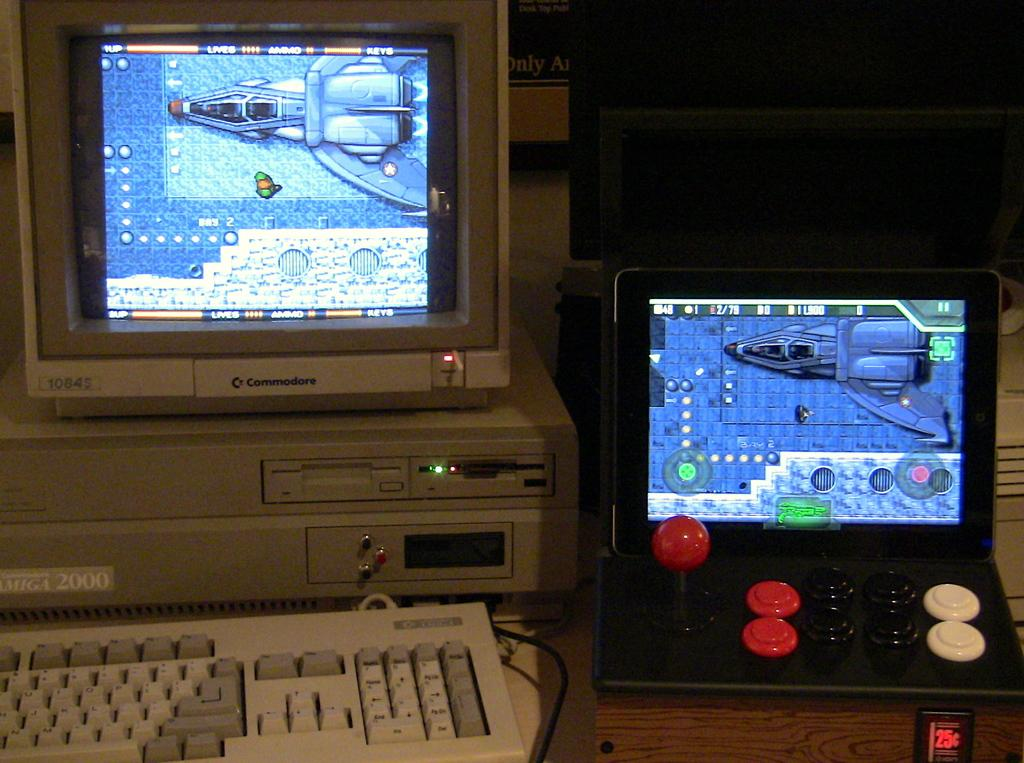What type of electronic devices can be seen in the image? There are PCs and a laptop in the image. What is used for typing in the image? There is a keyboard in the image. What else can be seen on the table in the image? There are other objects on the table in the image. Where might this image have been taken? The image was likely taken in a room. What type of drug is being used by the person in the image? There is no person or drug present in the image; it features electronic devices and a keyboard on a table. 